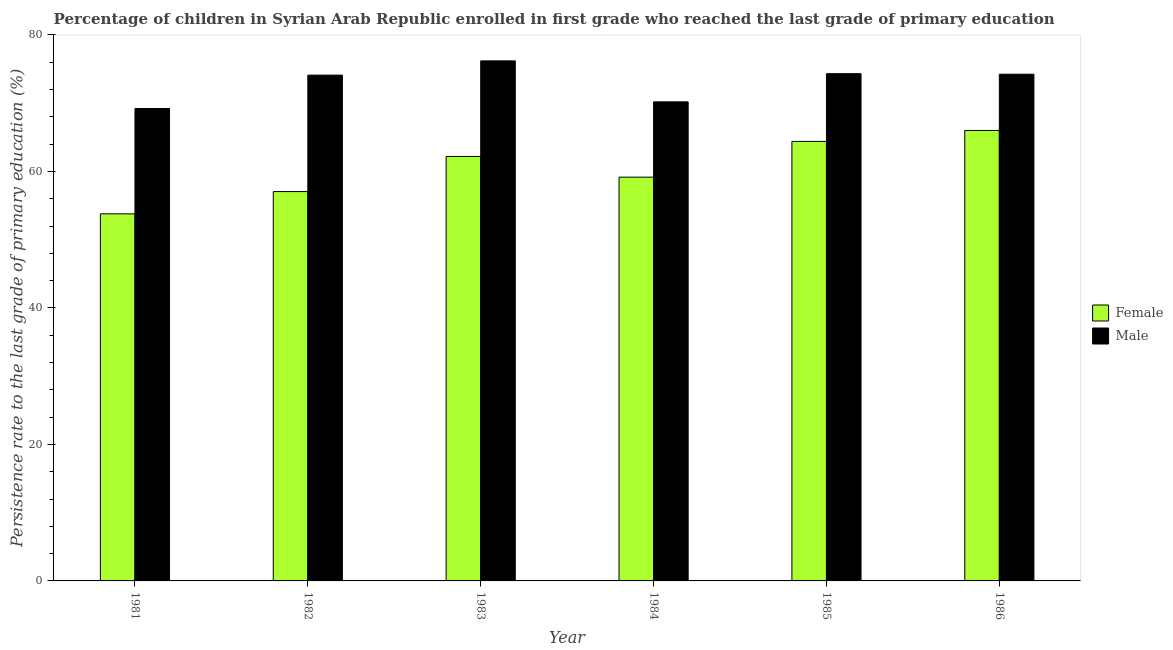How many different coloured bars are there?
Provide a short and direct response. 2. Are the number of bars per tick equal to the number of legend labels?
Keep it short and to the point. Yes. How many bars are there on the 1st tick from the left?
Provide a succinct answer. 2. How many bars are there on the 4th tick from the right?
Keep it short and to the point. 2. What is the persistence rate of male students in 1986?
Your response must be concise. 74.25. Across all years, what is the maximum persistence rate of male students?
Your response must be concise. 76.21. Across all years, what is the minimum persistence rate of female students?
Give a very brief answer. 53.79. In which year was the persistence rate of female students maximum?
Keep it short and to the point. 1986. What is the total persistence rate of male students in the graph?
Give a very brief answer. 438.33. What is the difference between the persistence rate of male students in 1983 and that in 1985?
Provide a succinct answer. 1.88. What is the difference between the persistence rate of female students in 1984 and the persistence rate of male students in 1981?
Offer a terse response. 5.38. What is the average persistence rate of male students per year?
Your answer should be very brief. 73.06. In the year 1985, what is the difference between the persistence rate of male students and persistence rate of female students?
Offer a terse response. 0. In how many years, is the persistence rate of male students greater than 64 %?
Ensure brevity in your answer.  6. What is the ratio of the persistence rate of male students in 1985 to that in 1986?
Your response must be concise. 1. Is the persistence rate of male students in 1985 less than that in 1986?
Provide a succinct answer. No. Is the difference between the persistence rate of female students in 1985 and 1986 greater than the difference between the persistence rate of male students in 1985 and 1986?
Your answer should be very brief. No. What is the difference between the highest and the second highest persistence rate of male students?
Your response must be concise. 1.88. What is the difference between the highest and the lowest persistence rate of female students?
Ensure brevity in your answer.  12.22. In how many years, is the persistence rate of male students greater than the average persistence rate of male students taken over all years?
Your answer should be very brief. 4. What does the 2nd bar from the left in 1983 represents?
Offer a terse response. Male. How many bars are there?
Provide a short and direct response. 12. Are all the bars in the graph horizontal?
Provide a succinct answer. No. What is the difference between two consecutive major ticks on the Y-axis?
Your answer should be compact. 20. Are the values on the major ticks of Y-axis written in scientific E-notation?
Offer a terse response. No. Does the graph contain any zero values?
Provide a succinct answer. No. Where does the legend appear in the graph?
Your answer should be very brief. Center right. How are the legend labels stacked?
Make the answer very short. Vertical. What is the title of the graph?
Your response must be concise. Percentage of children in Syrian Arab Republic enrolled in first grade who reached the last grade of primary education. Does "Diesel" appear as one of the legend labels in the graph?
Give a very brief answer. No. What is the label or title of the Y-axis?
Your response must be concise. Persistence rate to the last grade of primary education (%). What is the Persistence rate to the last grade of primary education (%) of Female in 1981?
Your response must be concise. 53.79. What is the Persistence rate to the last grade of primary education (%) of Male in 1981?
Provide a succinct answer. 69.22. What is the Persistence rate to the last grade of primary education (%) in Female in 1982?
Provide a succinct answer. 57.06. What is the Persistence rate to the last grade of primary education (%) of Male in 1982?
Give a very brief answer. 74.12. What is the Persistence rate to the last grade of primary education (%) in Female in 1983?
Offer a very short reply. 62.2. What is the Persistence rate to the last grade of primary education (%) in Male in 1983?
Ensure brevity in your answer.  76.21. What is the Persistence rate to the last grade of primary education (%) of Female in 1984?
Your answer should be very brief. 59.17. What is the Persistence rate to the last grade of primary education (%) of Male in 1984?
Give a very brief answer. 70.2. What is the Persistence rate to the last grade of primary education (%) in Female in 1985?
Your answer should be compact. 64.4. What is the Persistence rate to the last grade of primary education (%) of Male in 1985?
Make the answer very short. 74.33. What is the Persistence rate to the last grade of primary education (%) in Female in 1986?
Give a very brief answer. 66.01. What is the Persistence rate to the last grade of primary education (%) of Male in 1986?
Your answer should be very brief. 74.25. Across all years, what is the maximum Persistence rate to the last grade of primary education (%) of Female?
Keep it short and to the point. 66.01. Across all years, what is the maximum Persistence rate to the last grade of primary education (%) in Male?
Provide a succinct answer. 76.21. Across all years, what is the minimum Persistence rate to the last grade of primary education (%) of Female?
Provide a short and direct response. 53.79. Across all years, what is the minimum Persistence rate to the last grade of primary education (%) of Male?
Your response must be concise. 69.22. What is the total Persistence rate to the last grade of primary education (%) of Female in the graph?
Provide a succinct answer. 362.63. What is the total Persistence rate to the last grade of primary education (%) in Male in the graph?
Ensure brevity in your answer.  438.33. What is the difference between the Persistence rate to the last grade of primary education (%) of Female in 1981 and that in 1982?
Provide a short and direct response. -3.26. What is the difference between the Persistence rate to the last grade of primary education (%) in Male in 1981 and that in 1982?
Make the answer very short. -4.89. What is the difference between the Persistence rate to the last grade of primary education (%) in Female in 1981 and that in 1983?
Provide a succinct answer. -8.41. What is the difference between the Persistence rate to the last grade of primary education (%) in Male in 1981 and that in 1983?
Make the answer very short. -6.98. What is the difference between the Persistence rate to the last grade of primary education (%) of Female in 1981 and that in 1984?
Your answer should be compact. -5.38. What is the difference between the Persistence rate to the last grade of primary education (%) in Male in 1981 and that in 1984?
Your response must be concise. -0.98. What is the difference between the Persistence rate to the last grade of primary education (%) of Female in 1981 and that in 1985?
Ensure brevity in your answer.  -10.61. What is the difference between the Persistence rate to the last grade of primary education (%) of Male in 1981 and that in 1985?
Keep it short and to the point. -5.1. What is the difference between the Persistence rate to the last grade of primary education (%) of Female in 1981 and that in 1986?
Provide a succinct answer. -12.22. What is the difference between the Persistence rate to the last grade of primary education (%) of Male in 1981 and that in 1986?
Your response must be concise. -5.03. What is the difference between the Persistence rate to the last grade of primary education (%) of Female in 1982 and that in 1983?
Keep it short and to the point. -5.15. What is the difference between the Persistence rate to the last grade of primary education (%) of Male in 1982 and that in 1983?
Make the answer very short. -2.09. What is the difference between the Persistence rate to the last grade of primary education (%) of Female in 1982 and that in 1984?
Your answer should be very brief. -2.11. What is the difference between the Persistence rate to the last grade of primary education (%) in Male in 1982 and that in 1984?
Offer a terse response. 3.92. What is the difference between the Persistence rate to the last grade of primary education (%) in Female in 1982 and that in 1985?
Your answer should be very brief. -7.35. What is the difference between the Persistence rate to the last grade of primary education (%) in Male in 1982 and that in 1985?
Provide a succinct answer. -0.21. What is the difference between the Persistence rate to the last grade of primary education (%) of Female in 1982 and that in 1986?
Make the answer very short. -8.95. What is the difference between the Persistence rate to the last grade of primary education (%) of Male in 1982 and that in 1986?
Your response must be concise. -0.13. What is the difference between the Persistence rate to the last grade of primary education (%) of Female in 1983 and that in 1984?
Offer a very short reply. 3.03. What is the difference between the Persistence rate to the last grade of primary education (%) of Male in 1983 and that in 1984?
Provide a succinct answer. 6.01. What is the difference between the Persistence rate to the last grade of primary education (%) of Female in 1983 and that in 1985?
Your response must be concise. -2.2. What is the difference between the Persistence rate to the last grade of primary education (%) of Male in 1983 and that in 1985?
Your answer should be very brief. 1.88. What is the difference between the Persistence rate to the last grade of primary education (%) of Female in 1983 and that in 1986?
Make the answer very short. -3.81. What is the difference between the Persistence rate to the last grade of primary education (%) in Male in 1983 and that in 1986?
Give a very brief answer. 1.95. What is the difference between the Persistence rate to the last grade of primary education (%) in Female in 1984 and that in 1985?
Your answer should be compact. -5.24. What is the difference between the Persistence rate to the last grade of primary education (%) in Male in 1984 and that in 1985?
Offer a very short reply. -4.13. What is the difference between the Persistence rate to the last grade of primary education (%) in Female in 1984 and that in 1986?
Keep it short and to the point. -6.84. What is the difference between the Persistence rate to the last grade of primary education (%) in Male in 1984 and that in 1986?
Keep it short and to the point. -4.05. What is the difference between the Persistence rate to the last grade of primary education (%) of Female in 1985 and that in 1986?
Your response must be concise. -1.61. What is the difference between the Persistence rate to the last grade of primary education (%) in Male in 1985 and that in 1986?
Provide a succinct answer. 0.08. What is the difference between the Persistence rate to the last grade of primary education (%) in Female in 1981 and the Persistence rate to the last grade of primary education (%) in Male in 1982?
Your answer should be very brief. -20.33. What is the difference between the Persistence rate to the last grade of primary education (%) in Female in 1981 and the Persistence rate to the last grade of primary education (%) in Male in 1983?
Your response must be concise. -22.42. What is the difference between the Persistence rate to the last grade of primary education (%) of Female in 1981 and the Persistence rate to the last grade of primary education (%) of Male in 1984?
Your answer should be very brief. -16.41. What is the difference between the Persistence rate to the last grade of primary education (%) of Female in 1981 and the Persistence rate to the last grade of primary education (%) of Male in 1985?
Offer a very short reply. -20.54. What is the difference between the Persistence rate to the last grade of primary education (%) in Female in 1981 and the Persistence rate to the last grade of primary education (%) in Male in 1986?
Offer a terse response. -20.46. What is the difference between the Persistence rate to the last grade of primary education (%) of Female in 1982 and the Persistence rate to the last grade of primary education (%) of Male in 1983?
Offer a very short reply. -19.15. What is the difference between the Persistence rate to the last grade of primary education (%) in Female in 1982 and the Persistence rate to the last grade of primary education (%) in Male in 1984?
Your response must be concise. -13.14. What is the difference between the Persistence rate to the last grade of primary education (%) of Female in 1982 and the Persistence rate to the last grade of primary education (%) of Male in 1985?
Your response must be concise. -17.27. What is the difference between the Persistence rate to the last grade of primary education (%) of Female in 1982 and the Persistence rate to the last grade of primary education (%) of Male in 1986?
Provide a short and direct response. -17.2. What is the difference between the Persistence rate to the last grade of primary education (%) of Female in 1983 and the Persistence rate to the last grade of primary education (%) of Male in 1984?
Your response must be concise. -8. What is the difference between the Persistence rate to the last grade of primary education (%) of Female in 1983 and the Persistence rate to the last grade of primary education (%) of Male in 1985?
Keep it short and to the point. -12.13. What is the difference between the Persistence rate to the last grade of primary education (%) in Female in 1983 and the Persistence rate to the last grade of primary education (%) in Male in 1986?
Your answer should be compact. -12.05. What is the difference between the Persistence rate to the last grade of primary education (%) of Female in 1984 and the Persistence rate to the last grade of primary education (%) of Male in 1985?
Ensure brevity in your answer.  -15.16. What is the difference between the Persistence rate to the last grade of primary education (%) of Female in 1984 and the Persistence rate to the last grade of primary education (%) of Male in 1986?
Give a very brief answer. -15.08. What is the difference between the Persistence rate to the last grade of primary education (%) in Female in 1985 and the Persistence rate to the last grade of primary education (%) in Male in 1986?
Your answer should be very brief. -9.85. What is the average Persistence rate to the last grade of primary education (%) of Female per year?
Your answer should be compact. 60.44. What is the average Persistence rate to the last grade of primary education (%) in Male per year?
Your answer should be compact. 73.06. In the year 1981, what is the difference between the Persistence rate to the last grade of primary education (%) in Female and Persistence rate to the last grade of primary education (%) in Male?
Your answer should be compact. -15.43. In the year 1982, what is the difference between the Persistence rate to the last grade of primary education (%) in Female and Persistence rate to the last grade of primary education (%) in Male?
Provide a succinct answer. -17.06. In the year 1983, what is the difference between the Persistence rate to the last grade of primary education (%) in Female and Persistence rate to the last grade of primary education (%) in Male?
Offer a very short reply. -14. In the year 1984, what is the difference between the Persistence rate to the last grade of primary education (%) of Female and Persistence rate to the last grade of primary education (%) of Male?
Offer a very short reply. -11.03. In the year 1985, what is the difference between the Persistence rate to the last grade of primary education (%) in Female and Persistence rate to the last grade of primary education (%) in Male?
Give a very brief answer. -9.93. In the year 1986, what is the difference between the Persistence rate to the last grade of primary education (%) in Female and Persistence rate to the last grade of primary education (%) in Male?
Offer a terse response. -8.24. What is the ratio of the Persistence rate to the last grade of primary education (%) in Female in 1981 to that in 1982?
Your answer should be very brief. 0.94. What is the ratio of the Persistence rate to the last grade of primary education (%) in Male in 1981 to that in 1982?
Give a very brief answer. 0.93. What is the ratio of the Persistence rate to the last grade of primary education (%) in Female in 1981 to that in 1983?
Your answer should be compact. 0.86. What is the ratio of the Persistence rate to the last grade of primary education (%) in Male in 1981 to that in 1983?
Ensure brevity in your answer.  0.91. What is the ratio of the Persistence rate to the last grade of primary education (%) in Male in 1981 to that in 1984?
Provide a succinct answer. 0.99. What is the ratio of the Persistence rate to the last grade of primary education (%) of Female in 1981 to that in 1985?
Provide a succinct answer. 0.84. What is the ratio of the Persistence rate to the last grade of primary education (%) in Male in 1981 to that in 1985?
Provide a short and direct response. 0.93. What is the ratio of the Persistence rate to the last grade of primary education (%) in Female in 1981 to that in 1986?
Ensure brevity in your answer.  0.81. What is the ratio of the Persistence rate to the last grade of primary education (%) in Male in 1981 to that in 1986?
Your response must be concise. 0.93. What is the ratio of the Persistence rate to the last grade of primary education (%) in Female in 1982 to that in 1983?
Offer a very short reply. 0.92. What is the ratio of the Persistence rate to the last grade of primary education (%) in Male in 1982 to that in 1983?
Provide a short and direct response. 0.97. What is the ratio of the Persistence rate to the last grade of primary education (%) of Female in 1982 to that in 1984?
Make the answer very short. 0.96. What is the ratio of the Persistence rate to the last grade of primary education (%) of Male in 1982 to that in 1984?
Give a very brief answer. 1.06. What is the ratio of the Persistence rate to the last grade of primary education (%) of Female in 1982 to that in 1985?
Ensure brevity in your answer.  0.89. What is the ratio of the Persistence rate to the last grade of primary education (%) of Female in 1982 to that in 1986?
Provide a short and direct response. 0.86. What is the ratio of the Persistence rate to the last grade of primary education (%) in Male in 1982 to that in 1986?
Ensure brevity in your answer.  1. What is the ratio of the Persistence rate to the last grade of primary education (%) in Female in 1983 to that in 1984?
Offer a terse response. 1.05. What is the ratio of the Persistence rate to the last grade of primary education (%) in Male in 1983 to that in 1984?
Offer a terse response. 1.09. What is the ratio of the Persistence rate to the last grade of primary education (%) in Female in 1983 to that in 1985?
Give a very brief answer. 0.97. What is the ratio of the Persistence rate to the last grade of primary education (%) of Male in 1983 to that in 1985?
Your answer should be very brief. 1.03. What is the ratio of the Persistence rate to the last grade of primary education (%) of Female in 1983 to that in 1986?
Offer a very short reply. 0.94. What is the ratio of the Persistence rate to the last grade of primary education (%) in Male in 1983 to that in 1986?
Provide a short and direct response. 1.03. What is the ratio of the Persistence rate to the last grade of primary education (%) in Female in 1984 to that in 1985?
Your answer should be very brief. 0.92. What is the ratio of the Persistence rate to the last grade of primary education (%) in Female in 1984 to that in 1986?
Provide a short and direct response. 0.9. What is the ratio of the Persistence rate to the last grade of primary education (%) in Male in 1984 to that in 1986?
Give a very brief answer. 0.95. What is the ratio of the Persistence rate to the last grade of primary education (%) of Female in 1985 to that in 1986?
Provide a succinct answer. 0.98. What is the difference between the highest and the second highest Persistence rate to the last grade of primary education (%) in Female?
Provide a short and direct response. 1.61. What is the difference between the highest and the second highest Persistence rate to the last grade of primary education (%) in Male?
Offer a terse response. 1.88. What is the difference between the highest and the lowest Persistence rate to the last grade of primary education (%) of Female?
Your response must be concise. 12.22. What is the difference between the highest and the lowest Persistence rate to the last grade of primary education (%) of Male?
Your answer should be compact. 6.98. 